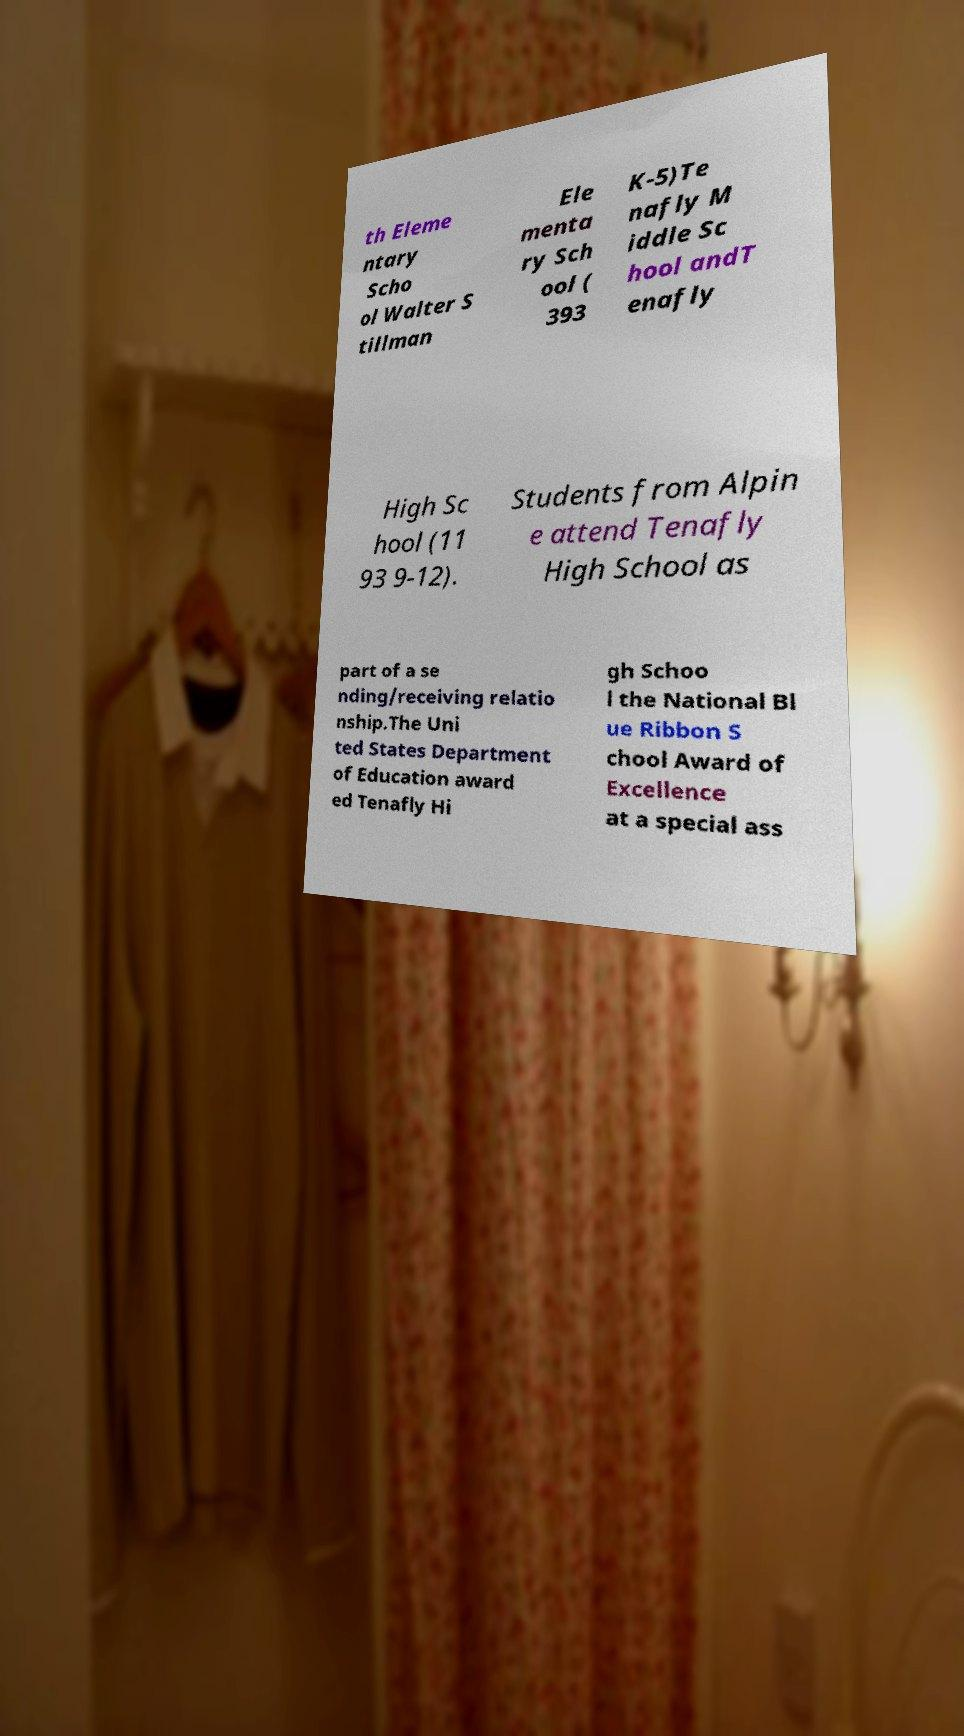Could you extract and type out the text from this image? th Eleme ntary Scho ol Walter S tillman Ele menta ry Sch ool ( 393 K-5)Te nafly M iddle Sc hool andT enafly High Sc hool (11 93 9-12). Students from Alpin e attend Tenafly High School as part of a se nding/receiving relatio nship.The Uni ted States Department of Education award ed Tenafly Hi gh Schoo l the National Bl ue Ribbon S chool Award of Excellence at a special ass 